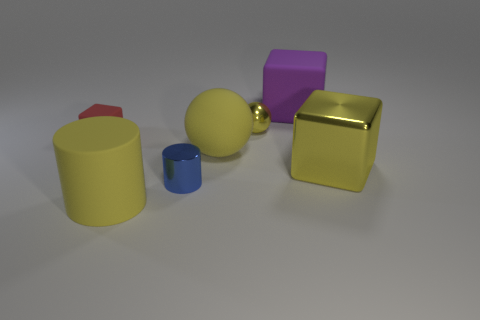Subtract all big cubes. How many cubes are left? 1 Add 2 tiny blocks. How many objects exist? 9 Subtract all cylinders. How many objects are left? 5 Add 7 yellow cylinders. How many yellow cylinders are left? 8 Add 2 red matte objects. How many red matte objects exist? 3 Subtract 0 gray cubes. How many objects are left? 7 Subtract all purple blocks. Subtract all big matte cubes. How many objects are left? 5 